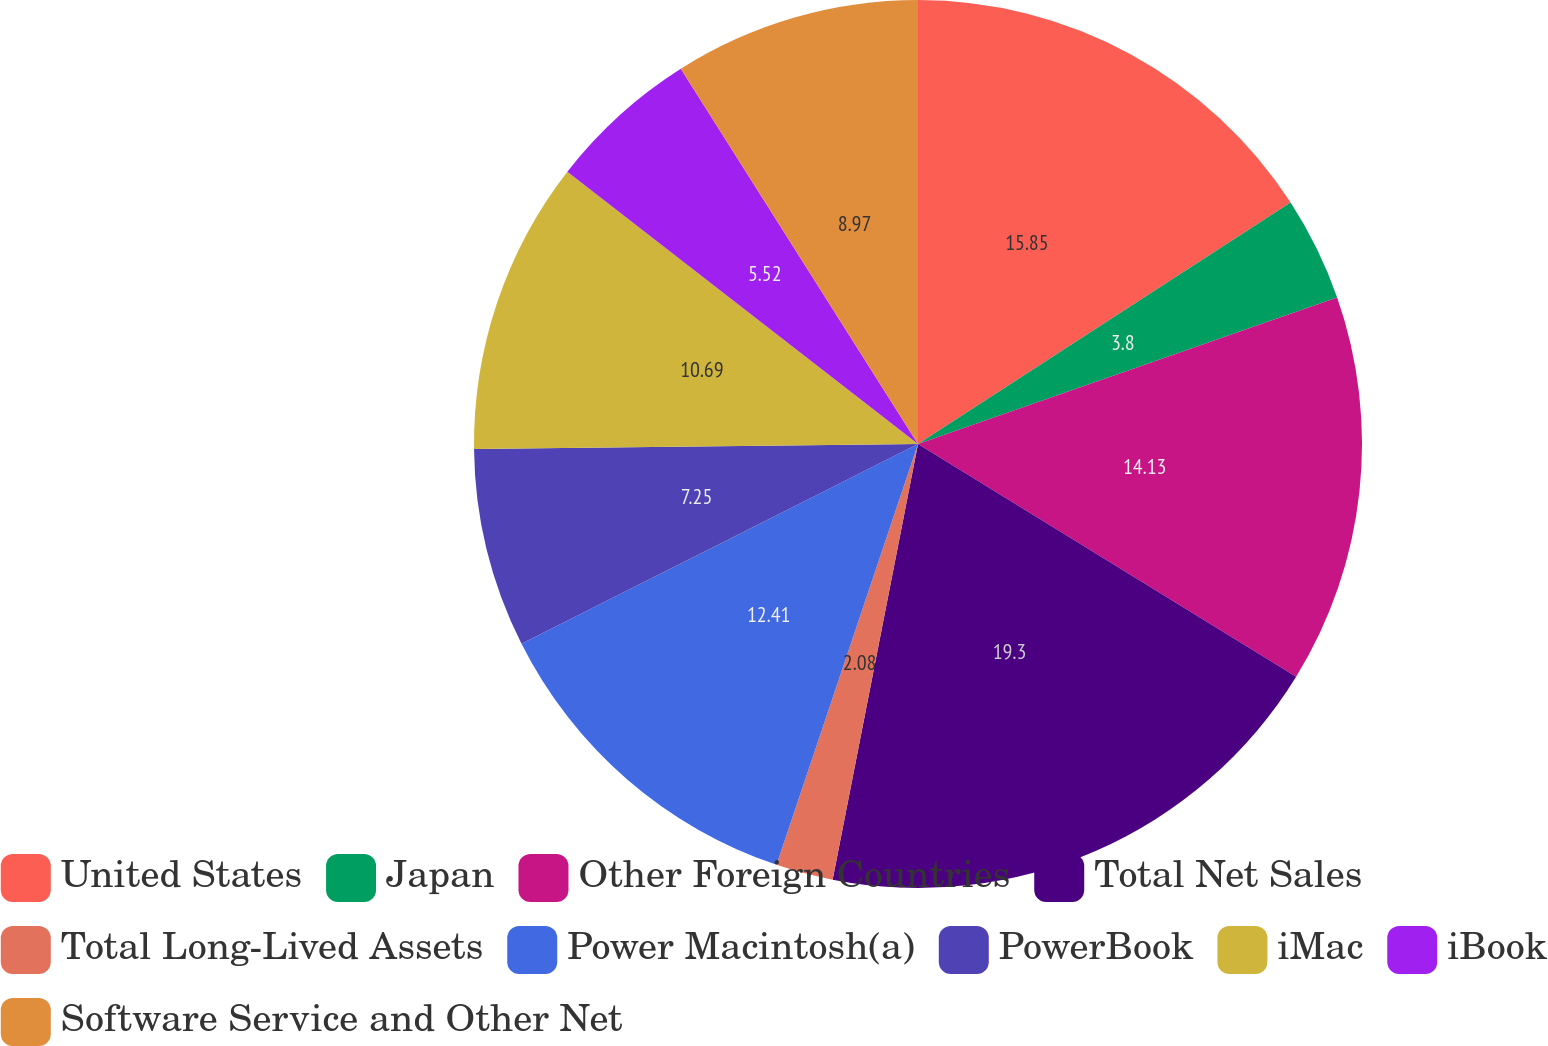<chart> <loc_0><loc_0><loc_500><loc_500><pie_chart><fcel>United States<fcel>Japan<fcel>Other Foreign Countries<fcel>Total Net Sales<fcel>Total Long-Lived Assets<fcel>Power Macintosh(a)<fcel>PowerBook<fcel>iMac<fcel>iBook<fcel>Software Service and Other Net<nl><fcel>15.85%<fcel>3.8%<fcel>14.13%<fcel>19.3%<fcel>2.08%<fcel>12.41%<fcel>7.25%<fcel>10.69%<fcel>5.52%<fcel>8.97%<nl></chart> 